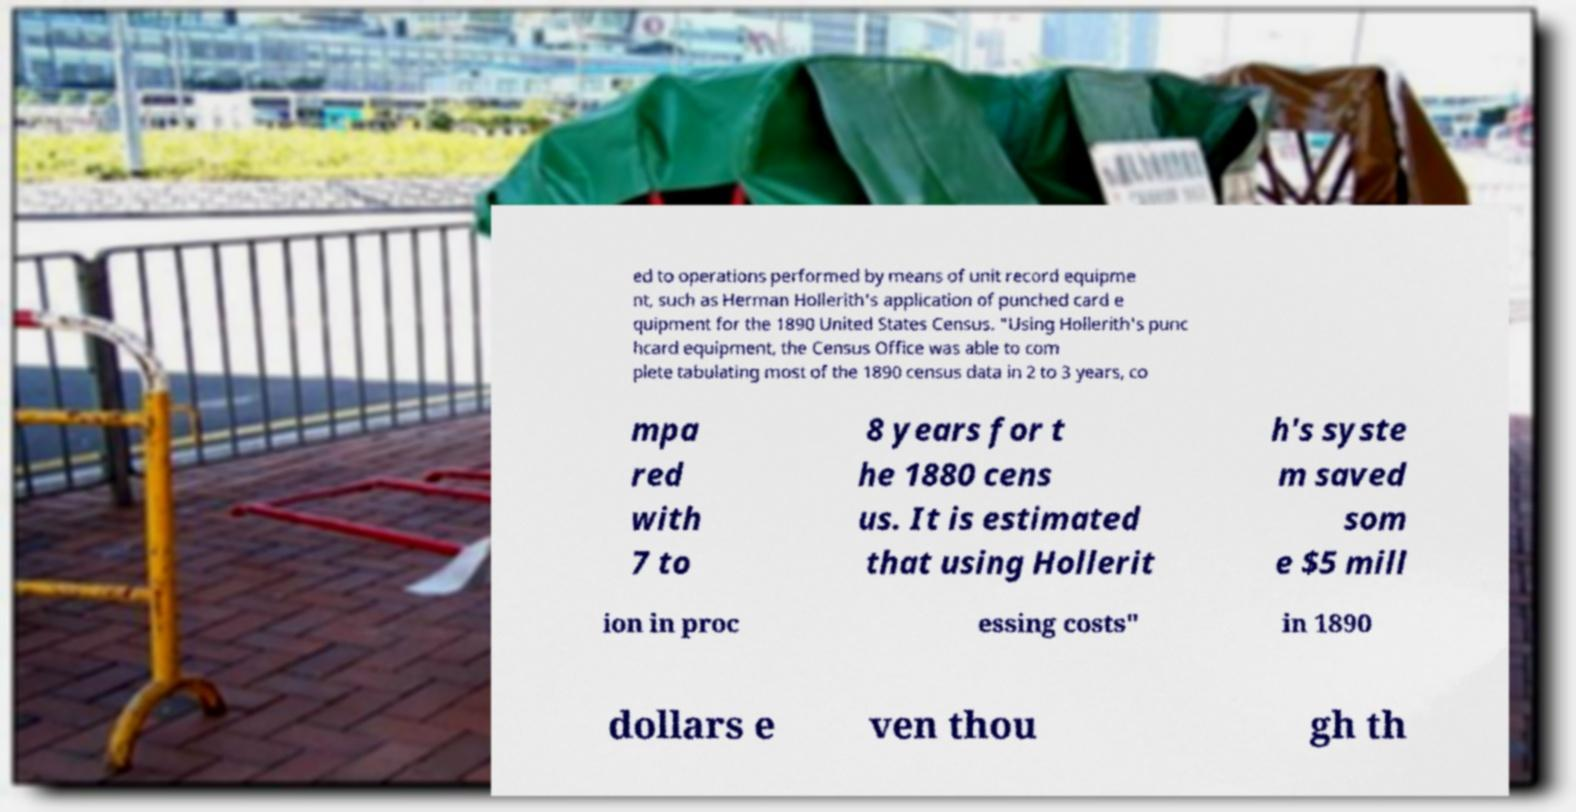Please identify and transcribe the text found in this image. ed to operations performed by means of unit record equipme nt, such as Herman Hollerith's application of punched card e quipment for the 1890 United States Census. "Using Hollerith's punc hcard equipment, the Census Office was able to com plete tabulating most of the 1890 census data in 2 to 3 years, co mpa red with 7 to 8 years for t he 1880 cens us. It is estimated that using Hollerit h's syste m saved som e $5 mill ion in proc essing costs" in 1890 dollars e ven thou gh th 